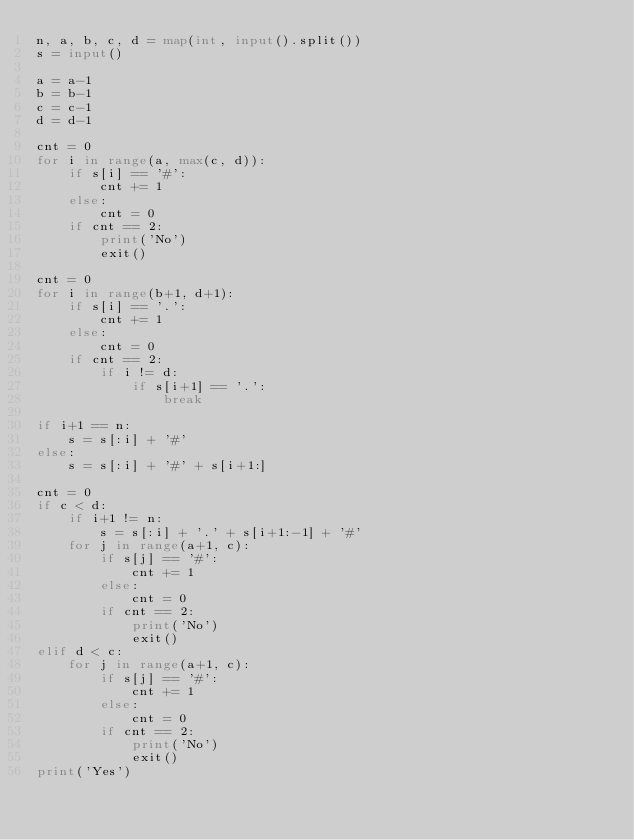Convert code to text. <code><loc_0><loc_0><loc_500><loc_500><_Python_>n, a, b, c, d = map(int, input().split())
s = input()

a = a-1
b = b-1
c = c-1
d = d-1

cnt = 0
for i in range(a, max(c, d)):
    if s[i] == '#':
        cnt += 1
    else:
        cnt = 0
    if cnt == 2:
        print('No')
        exit()

cnt = 0
for i in range(b+1, d+1):
    if s[i] == '.':
        cnt += 1
    else:
        cnt = 0
    if cnt == 2:
        if i != d:
            if s[i+1] == '.':
                break

if i+1 == n:
    s = s[:i] + '#'
else:
    s = s[:i] + '#' + s[i+1:]

cnt = 0
if c < d:
    if i+1 != n:
        s = s[:i] + '.' + s[i+1:-1] + '#'
    for j in range(a+1, c):
        if s[j] == '#':
            cnt += 1
        else:
            cnt = 0
        if cnt == 2:
            print('No')
            exit()
elif d < c:
    for j in range(a+1, c):
        if s[j] == '#':
            cnt += 1
        else:
            cnt = 0
        if cnt == 2:
            print('No')
            exit()
print('Yes')
</code> 